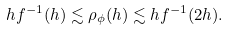Convert formula to latex. <formula><loc_0><loc_0><loc_500><loc_500>h f ^ { - 1 } ( h ) \lesssim \rho _ { \phi } ( h ) \lesssim h f ^ { - 1 } ( 2 h ) .</formula> 